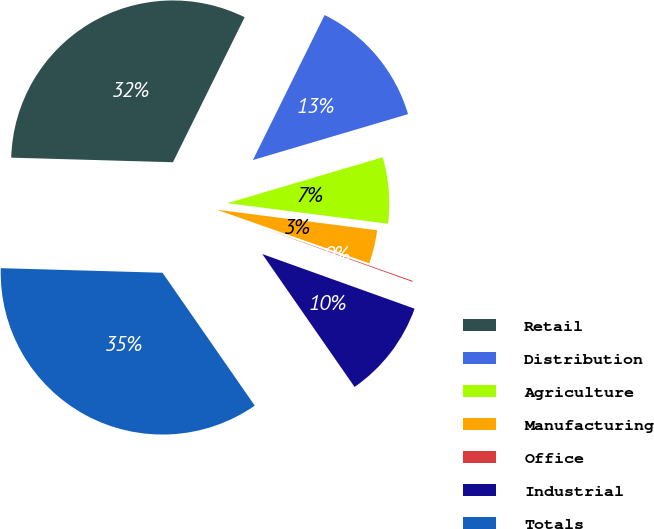<chart> <loc_0><loc_0><loc_500><loc_500><pie_chart><fcel>Retail<fcel>Distribution<fcel>Agriculture<fcel>Manufacturing<fcel>Office<fcel>Industrial<fcel>Totals<nl><fcel>31.86%<fcel>13.11%<fcel>6.61%<fcel>3.35%<fcel>0.1%<fcel>9.86%<fcel>35.11%<nl></chart> 